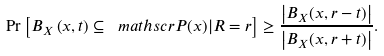<formula> <loc_0><loc_0><loc_500><loc_500>\Pr \left [ B _ { X } \left ( x , t \right ) \subseteq \ m a t h s c r P ( x ) | R = r \right ] \geq \frac { \left | B _ { X } ( x , r - t ) \right | } { \left | B _ { X } ( x , r + t ) \right | } .</formula> 